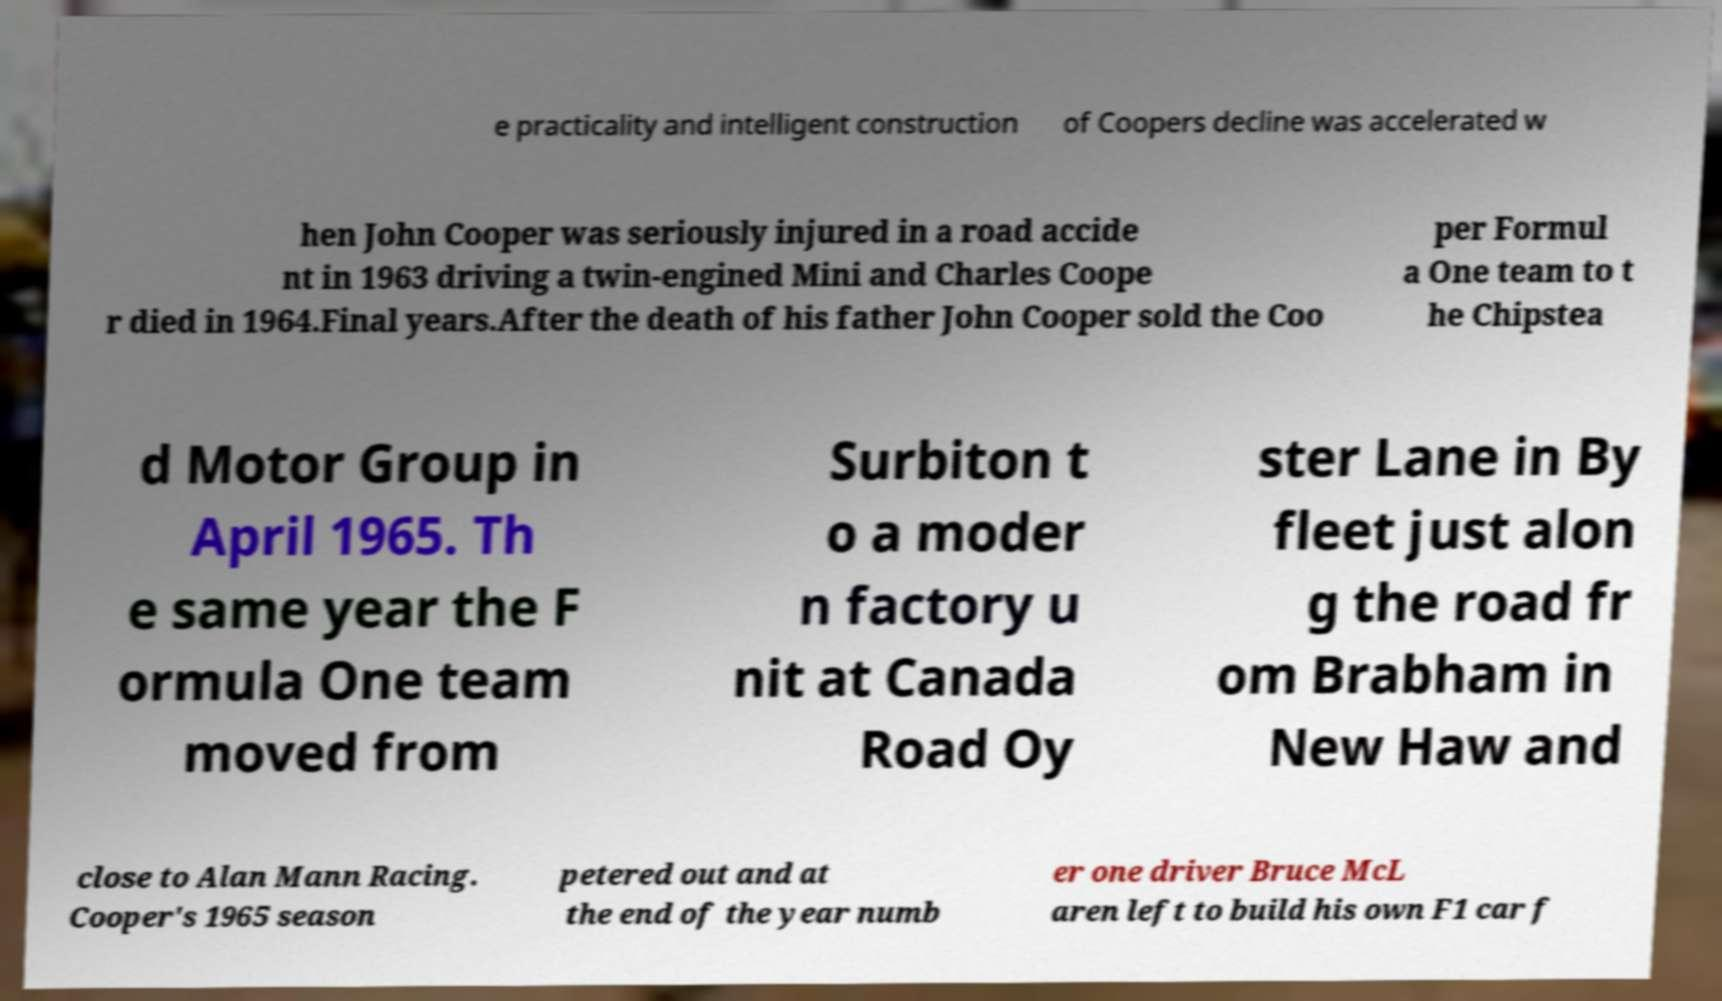Can you accurately transcribe the text from the provided image for me? e practicality and intelligent construction of Coopers decline was accelerated w hen John Cooper was seriously injured in a road accide nt in 1963 driving a twin-engined Mini and Charles Coope r died in 1964.Final years.After the death of his father John Cooper sold the Coo per Formul a One team to t he Chipstea d Motor Group in April 1965. Th e same year the F ormula One team moved from Surbiton t o a moder n factory u nit at Canada Road Oy ster Lane in By fleet just alon g the road fr om Brabham in New Haw and close to Alan Mann Racing. Cooper's 1965 season petered out and at the end of the year numb er one driver Bruce McL aren left to build his own F1 car f 